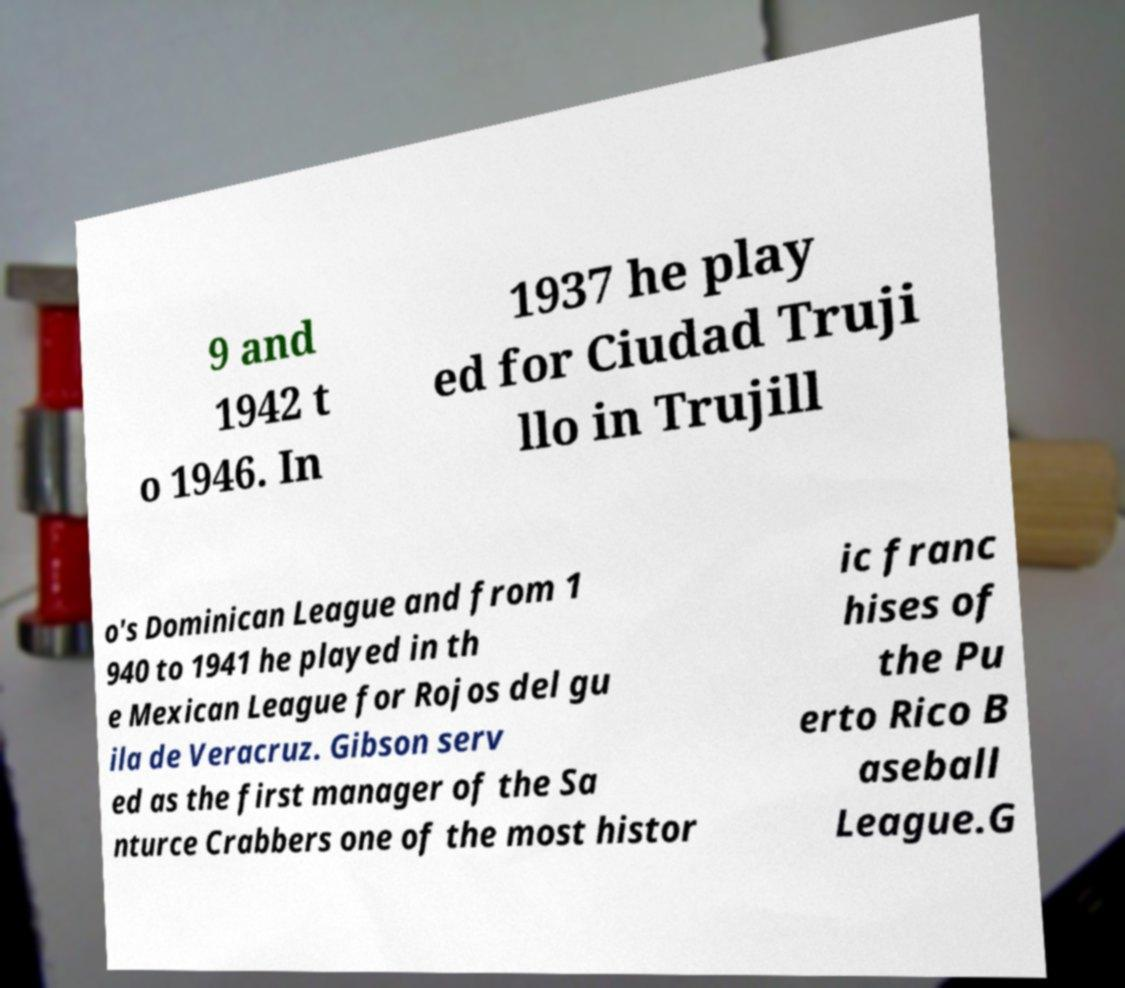Could you extract and type out the text from this image? 9 and 1942 t o 1946. In 1937 he play ed for Ciudad Truji llo in Trujill o's Dominican League and from 1 940 to 1941 he played in th e Mexican League for Rojos del gu ila de Veracruz. Gibson serv ed as the first manager of the Sa nturce Crabbers one of the most histor ic franc hises of the Pu erto Rico B aseball League.G 